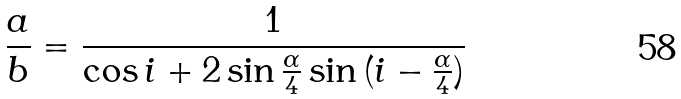<formula> <loc_0><loc_0><loc_500><loc_500>\frac { a } { b } = \frac { 1 } { \cos { i } + 2 \sin { \frac { \alpha } { 4 } } \sin { ( i - \frac { \alpha } { 4 } ) } }</formula> 